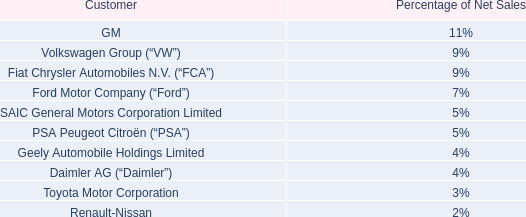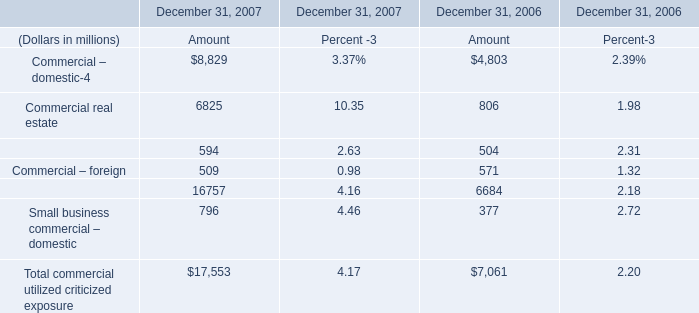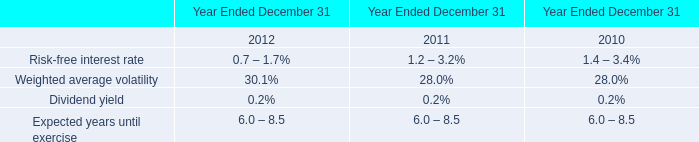What's the sum of the Commercial real estate in the years where Commercial lease financing is positive? (in millions) 
Computations: (6825 + 806)
Answer: 7631.0. 